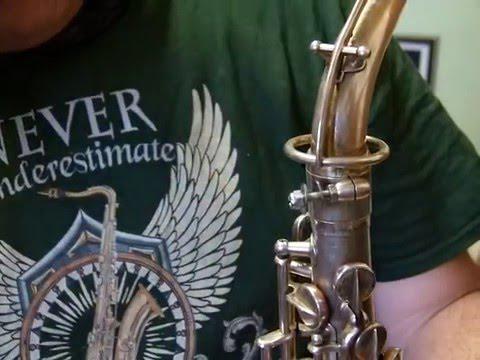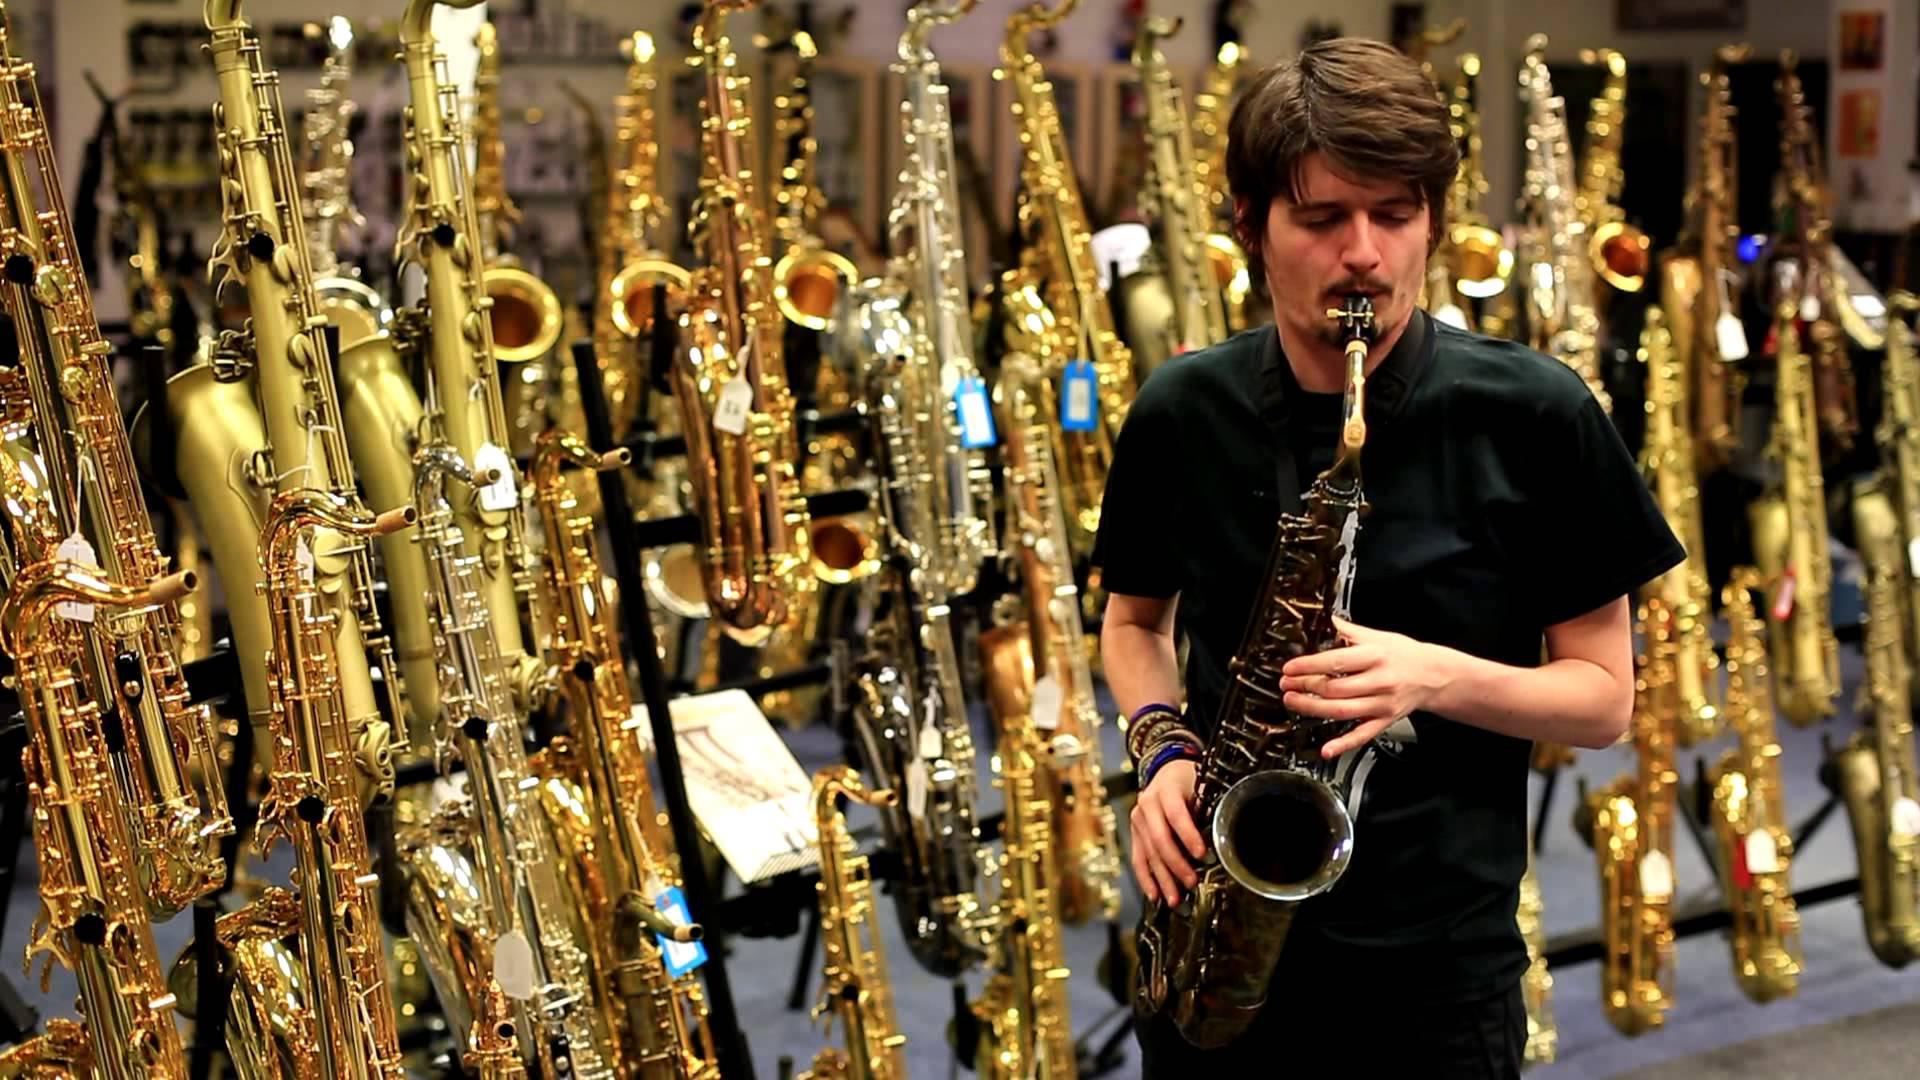The first image is the image on the left, the second image is the image on the right. Examine the images to the left and right. Is the description "Someone is playing a sax." accurate? Answer yes or no. Yes. The first image is the image on the left, the second image is the image on the right. Evaluate the accuracy of this statement regarding the images: "One image shows a man playing a saxophone and standing in front of a row of upright instruments.". Is it true? Answer yes or no. Yes. 